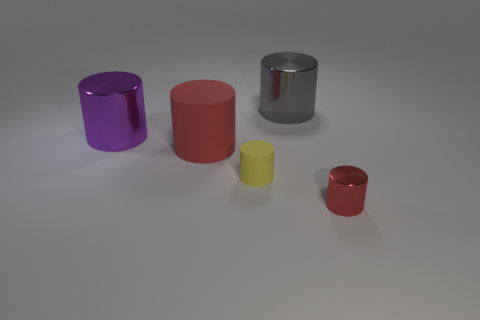Subtract all red cylinders. How many cylinders are left? 3 Subtract all yellow rubber cylinders. How many cylinders are left? 4 Subtract all blue cylinders. Subtract all cyan cubes. How many cylinders are left? 5 Add 1 big red cylinders. How many objects exist? 6 Add 5 small green matte spheres. How many small green matte spheres exist? 5 Subtract 0 brown spheres. How many objects are left? 5 Subtract all large cyan cylinders. Subtract all large gray things. How many objects are left? 4 Add 5 small metallic cylinders. How many small metallic cylinders are left? 6 